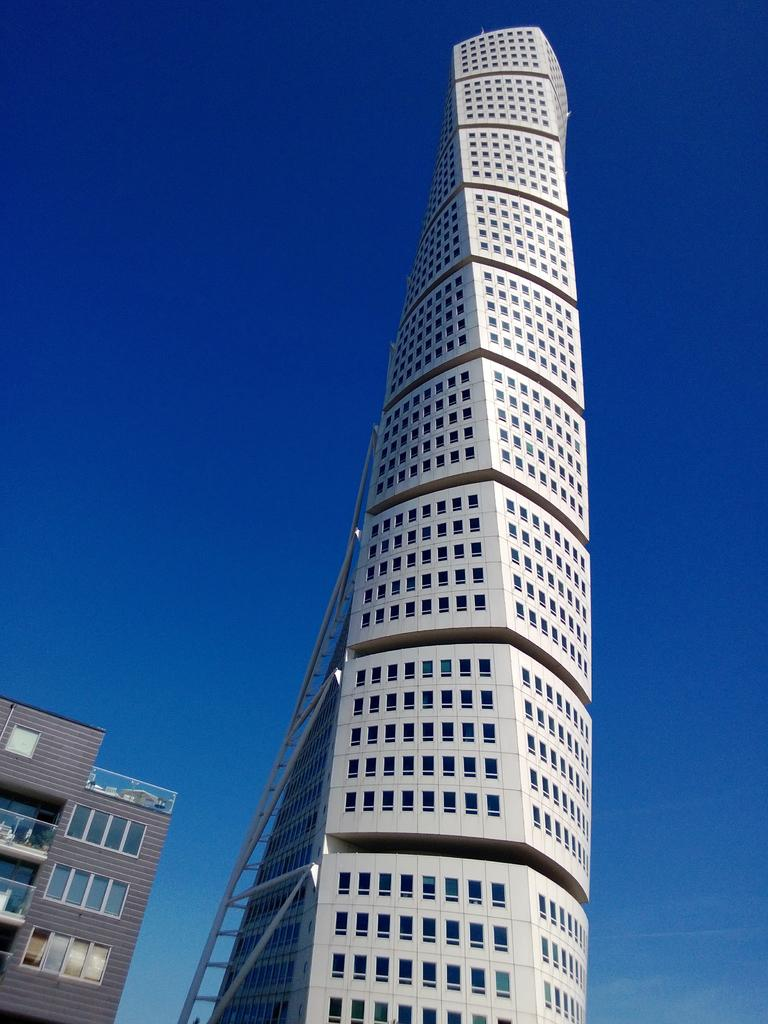What is the main structure in the image? There is a huge building with windows in the image. Are there any other buildings visible in the image? Yes, there is another building at the bottom left of the image. What can be seen in the background of the image? The sky is visible in the background of the image. How many boys are playing soccer in the image? There are no boys or soccer game present in the image. 